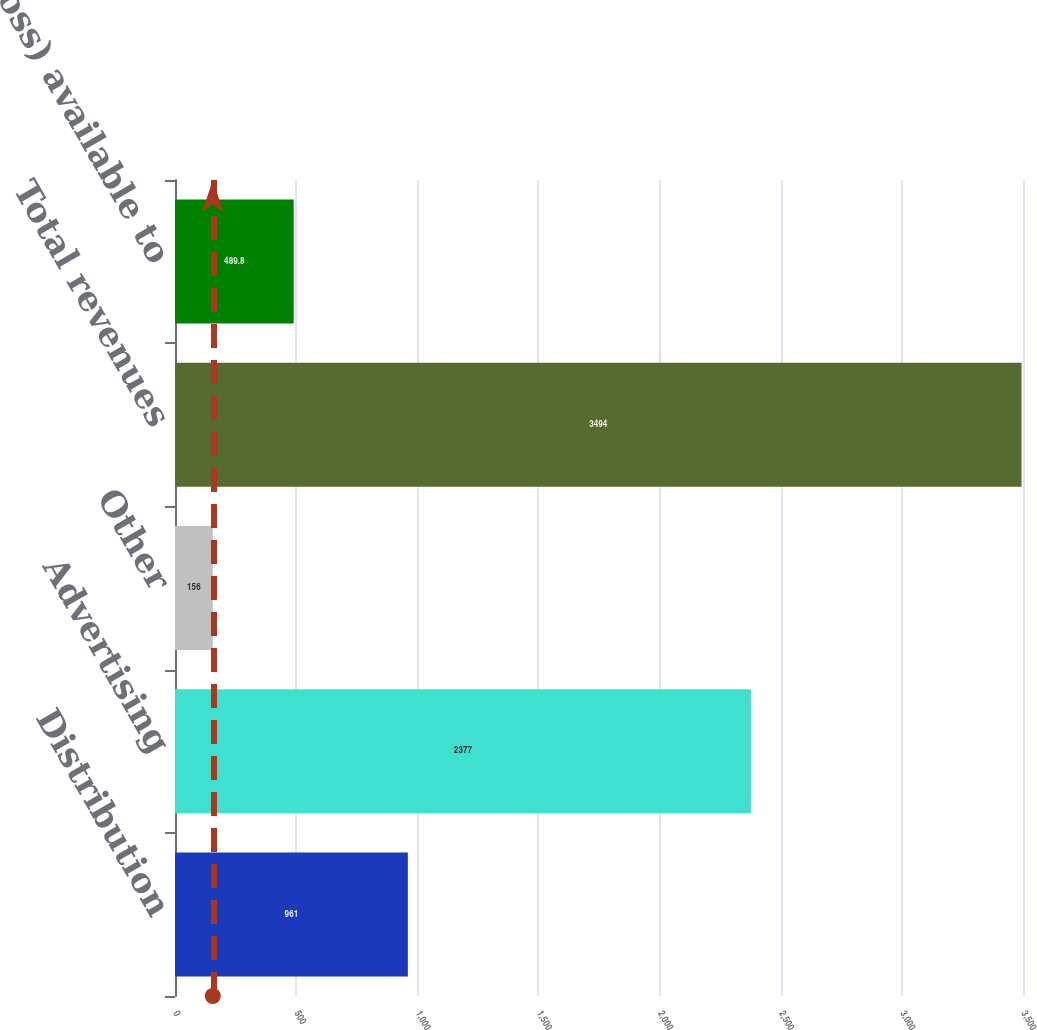Convert chart. <chart><loc_0><loc_0><loc_500><loc_500><bar_chart><fcel>Distribution<fcel>Advertising<fcel>Other<fcel>Total revenues<fcel>Net income (loss) available to<nl><fcel>961<fcel>2377<fcel>156<fcel>3494<fcel>489.8<nl></chart> 